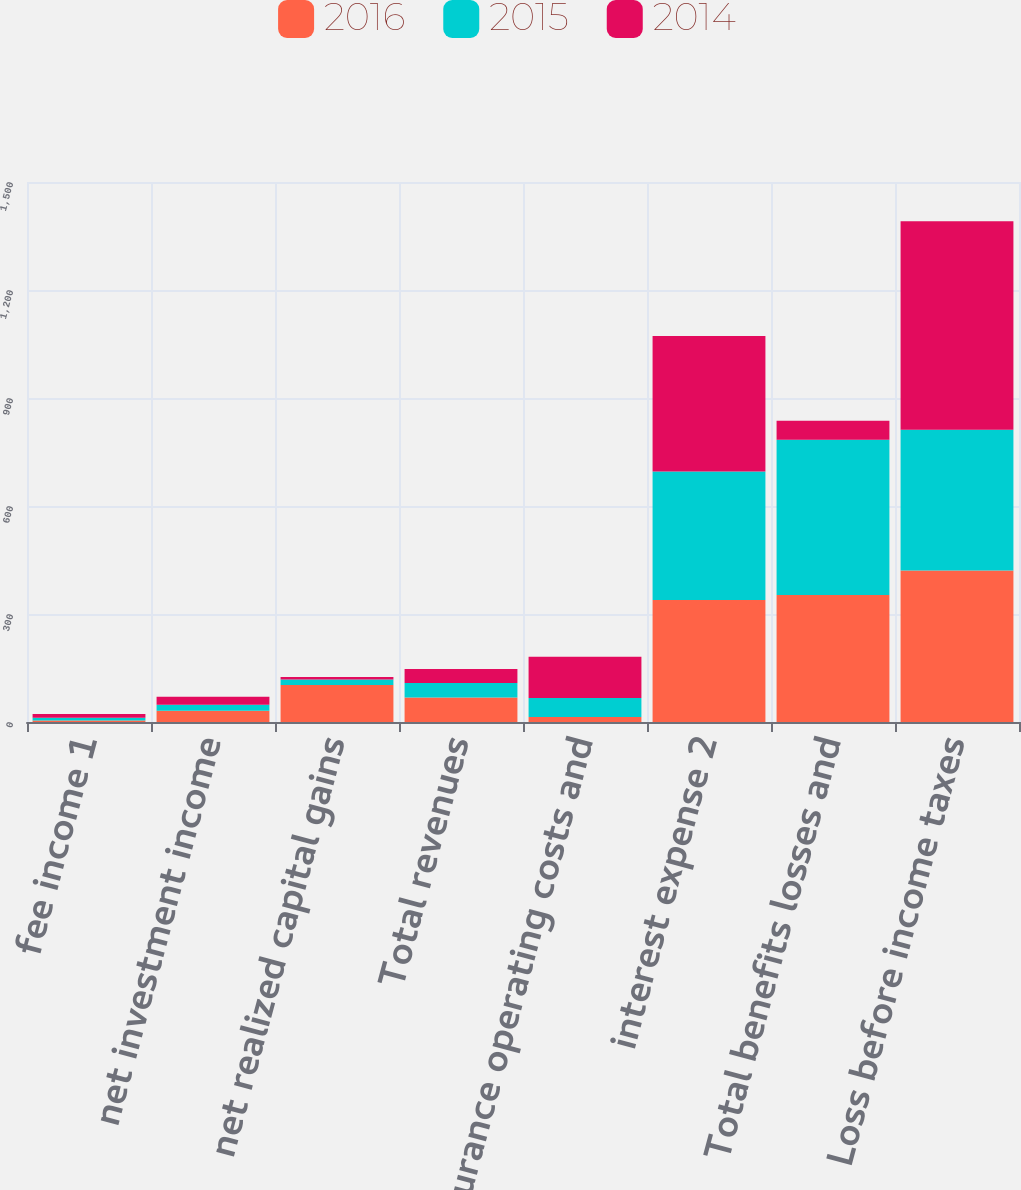Convert chart to OTSL. <chart><loc_0><loc_0><loc_500><loc_500><stacked_bar_chart><ecel><fcel>fee income 1<fcel>net investment income<fcel>net realized capital gains<fcel>Total revenues<fcel>insurance operating costs and<fcel>interest expense 2<fcel>Total benefits losses and<fcel>Loss before income taxes<nl><fcel>2016<fcel>4<fcel>31<fcel>103<fcel>68<fcel>14<fcel>339<fcel>353<fcel>421<nl><fcel>2015<fcel>8<fcel>17<fcel>15<fcel>40<fcel>53<fcel>357<fcel>431<fcel>391<nl><fcel>2014<fcel>10<fcel>22<fcel>7<fcel>39<fcel>114<fcel>376<fcel>53<fcel>579<nl></chart> 